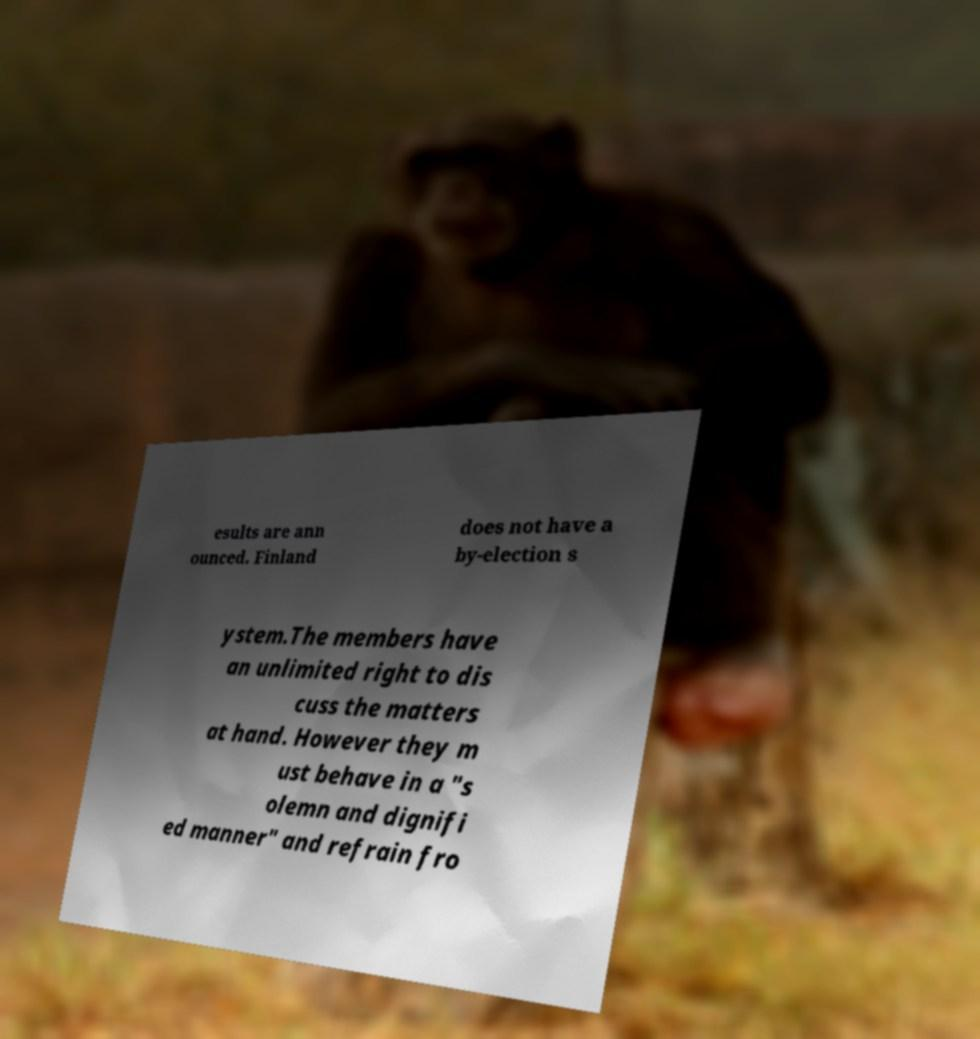Could you assist in decoding the text presented in this image and type it out clearly? esults are ann ounced. Finland does not have a by-election s ystem.The members have an unlimited right to dis cuss the matters at hand. However they m ust behave in a "s olemn and dignifi ed manner" and refrain fro 